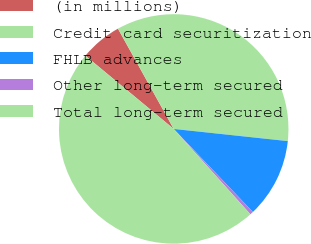Convert chart. <chart><loc_0><loc_0><loc_500><loc_500><pie_chart><fcel>(in millions)<fcel>Credit card securitization<fcel>FHLB advances<fcel>Other long-term secured<fcel>Total long-term secured<nl><fcel>5.9%<fcel>34.77%<fcel>11.19%<fcel>0.47%<fcel>47.67%<nl></chart> 